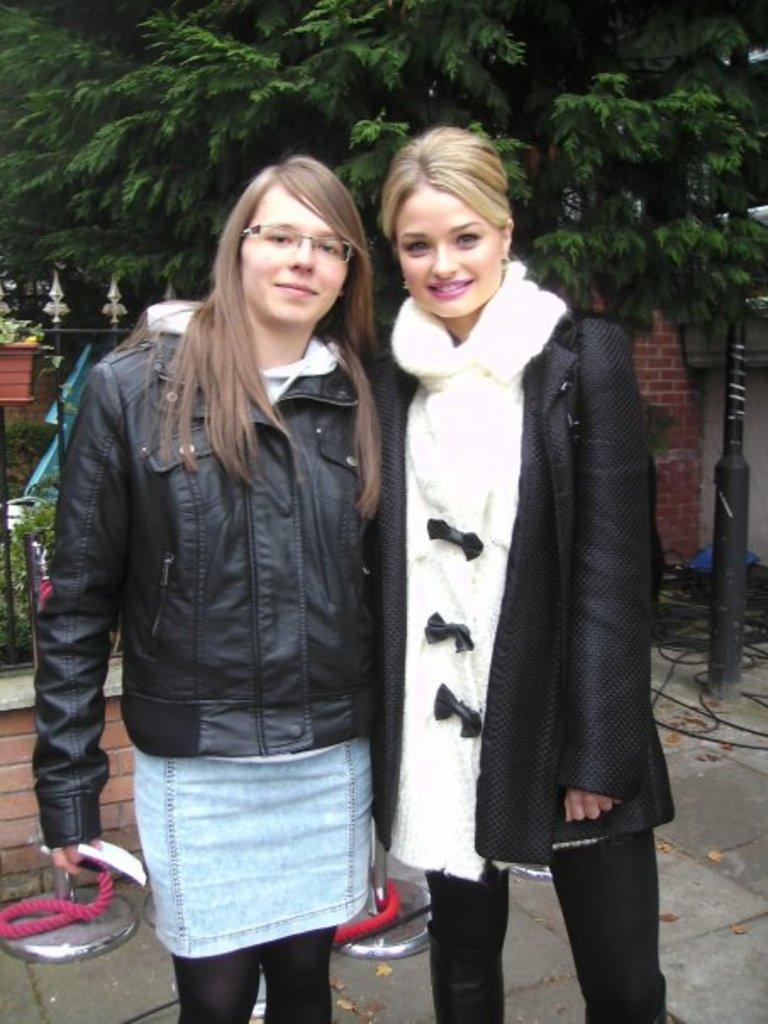Could you give a brief overview of what you see in this image? This image is taken outdoors. At the bottom of the image there is a floor. In the background there is a tree and there is a plant. There is a pot with a plant and there is a railing. In the middle of the image two women are standing on the floor and they are with smiling faces. 